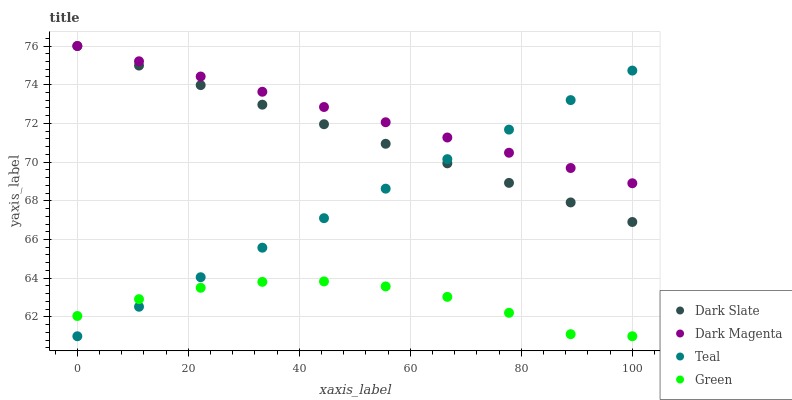Does Green have the minimum area under the curve?
Answer yes or no. Yes. Does Dark Magenta have the maximum area under the curve?
Answer yes or no. Yes. Does Dark Magenta have the minimum area under the curve?
Answer yes or no. No. Does Green have the maximum area under the curve?
Answer yes or no. No. Is Teal the smoothest?
Answer yes or no. Yes. Is Green the roughest?
Answer yes or no. Yes. Is Dark Magenta the smoothest?
Answer yes or no. No. Is Dark Magenta the roughest?
Answer yes or no. No. Does Green have the lowest value?
Answer yes or no. Yes. Does Dark Magenta have the lowest value?
Answer yes or no. No. Does Dark Magenta have the highest value?
Answer yes or no. Yes. Does Green have the highest value?
Answer yes or no. No. Is Green less than Dark Slate?
Answer yes or no. Yes. Is Dark Magenta greater than Green?
Answer yes or no. Yes. Does Green intersect Teal?
Answer yes or no. Yes. Is Green less than Teal?
Answer yes or no. No. Is Green greater than Teal?
Answer yes or no. No. Does Green intersect Dark Slate?
Answer yes or no. No. 